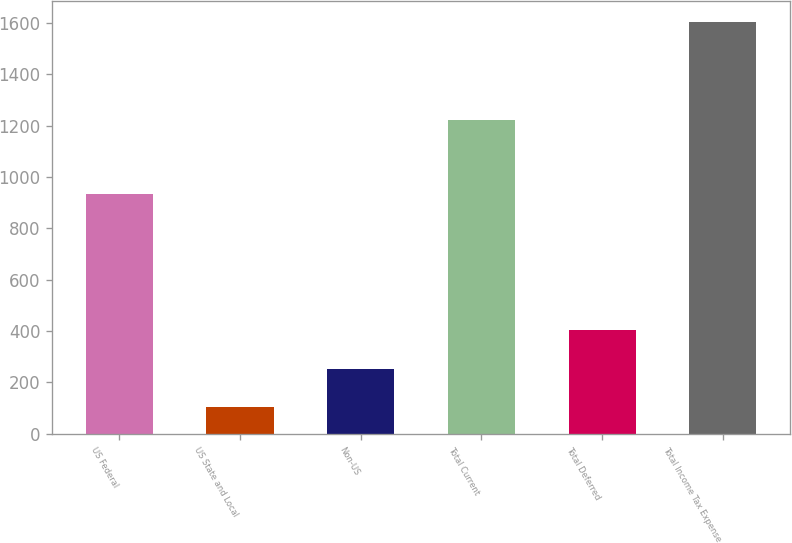Convert chart. <chart><loc_0><loc_0><loc_500><loc_500><bar_chart><fcel>US Federal<fcel>US State and Local<fcel>Non-US<fcel>Total Current<fcel>Total Deferred<fcel>Total Income Tax Expense<nl><fcel>932<fcel>103<fcel>253.2<fcel>1220<fcel>403.4<fcel>1605<nl></chart> 